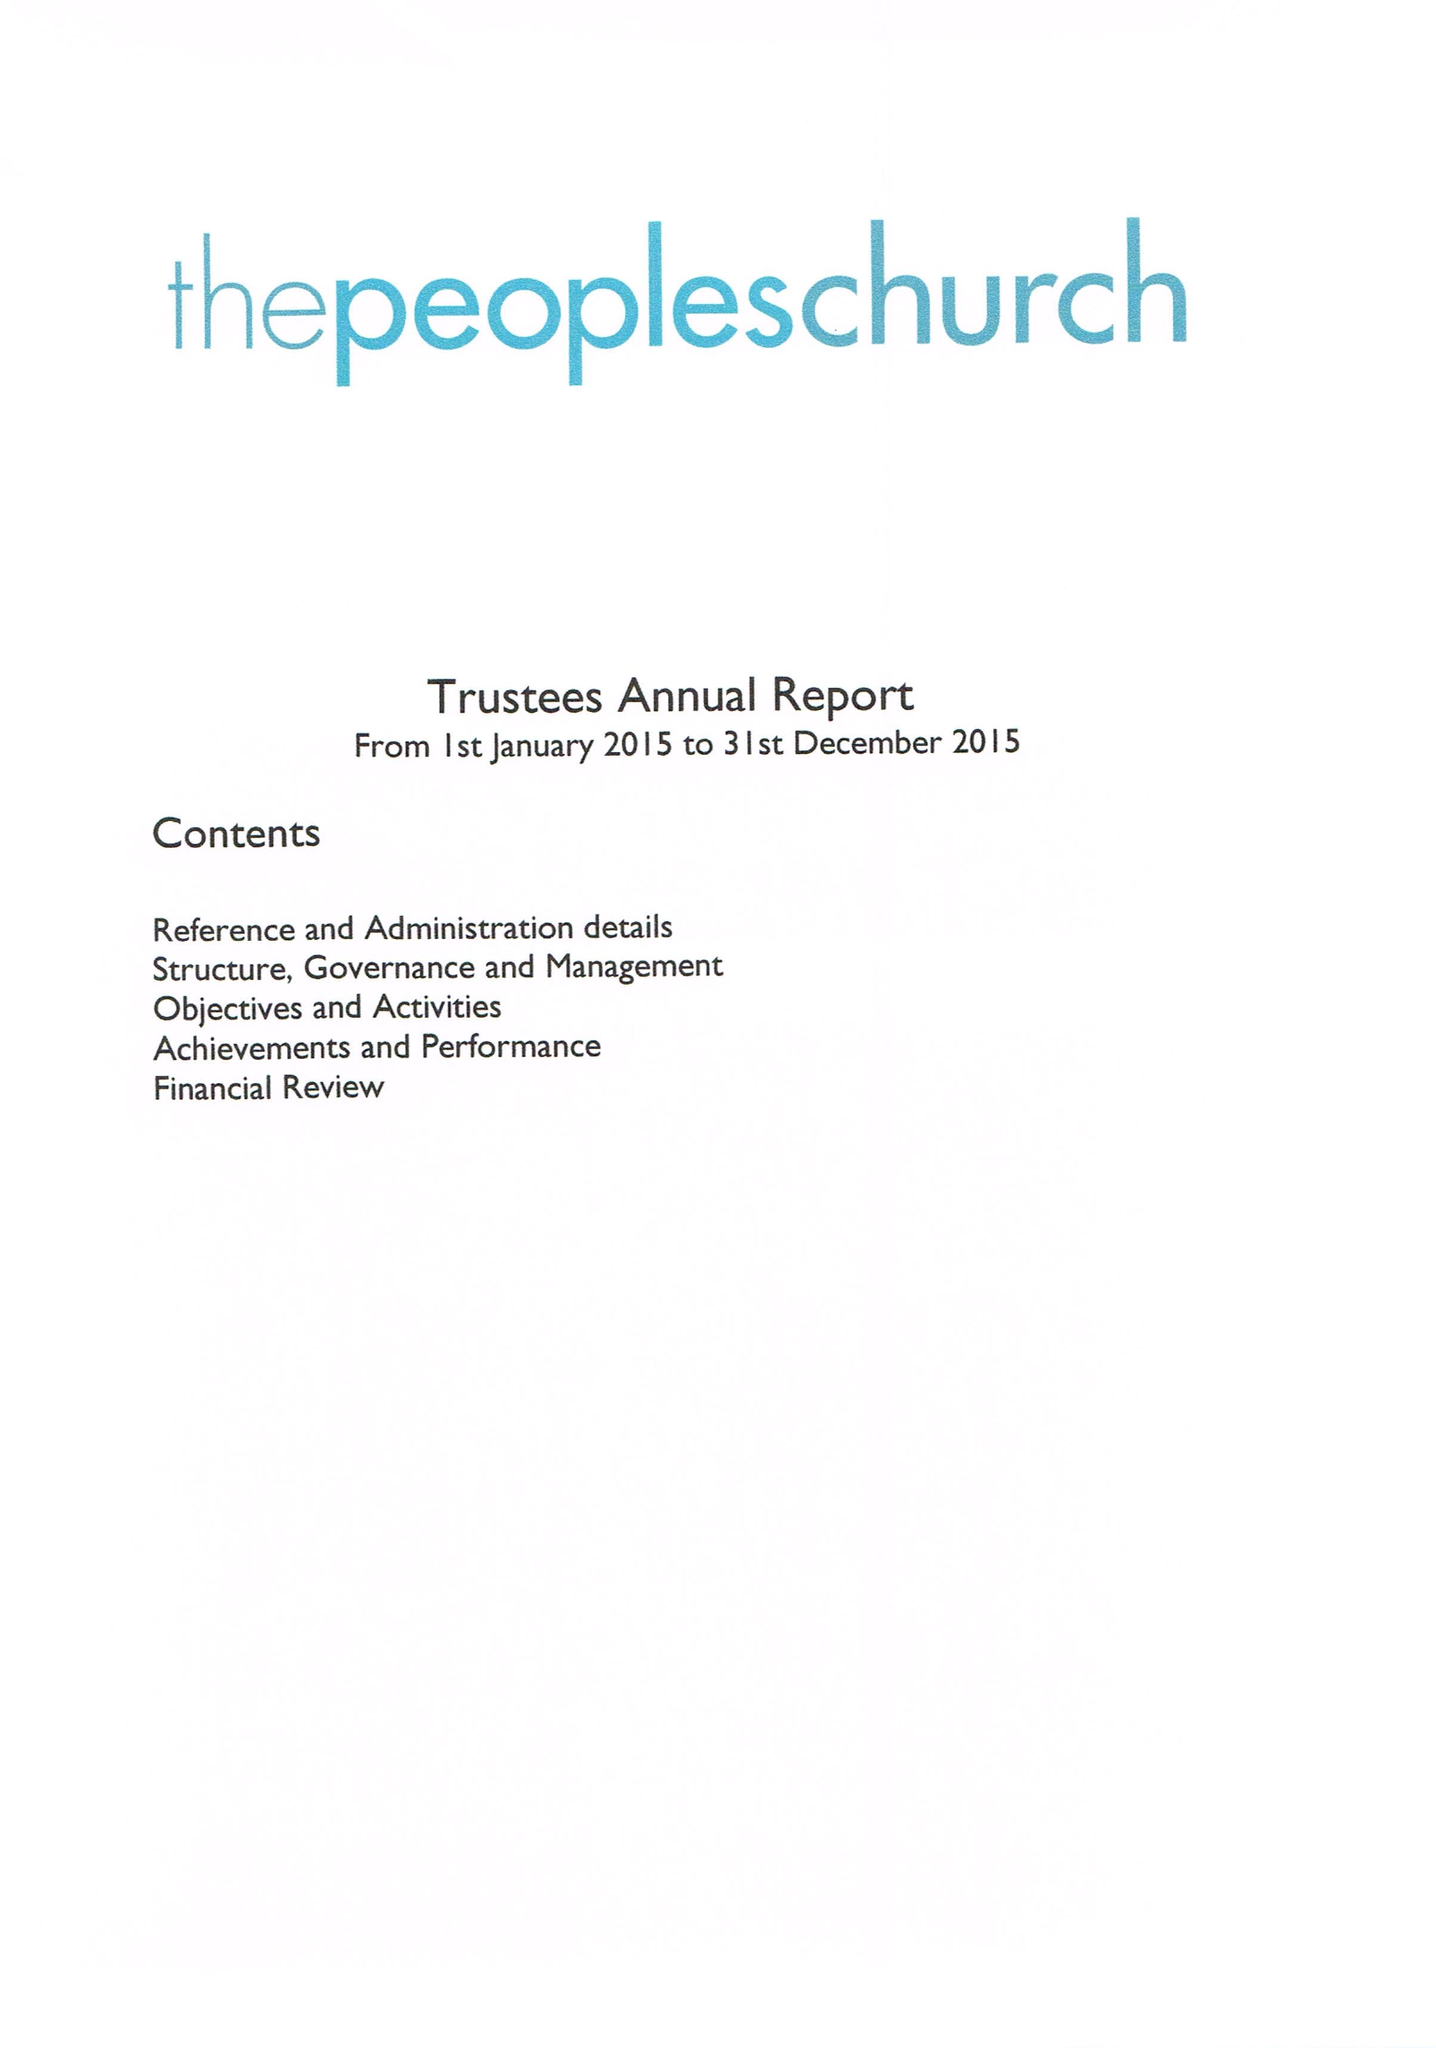What is the value for the charity_number?
Answer the question using a single word or phrase. 1137118 